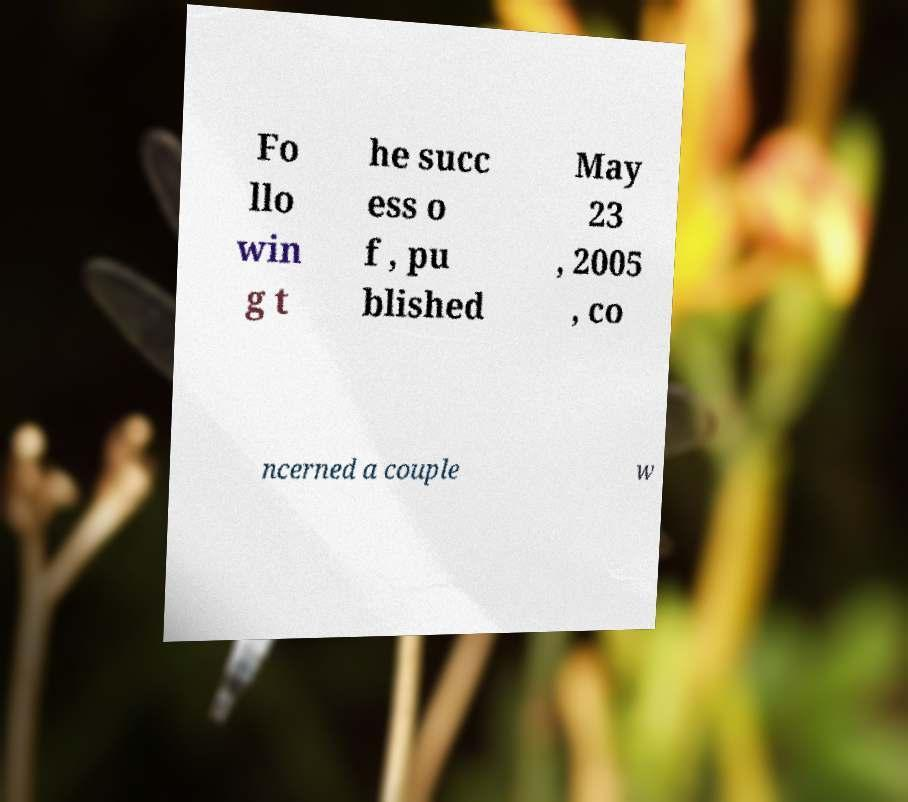I need the written content from this picture converted into text. Can you do that? Fo llo win g t he succ ess o f , pu blished May 23 , 2005 , co ncerned a couple w 